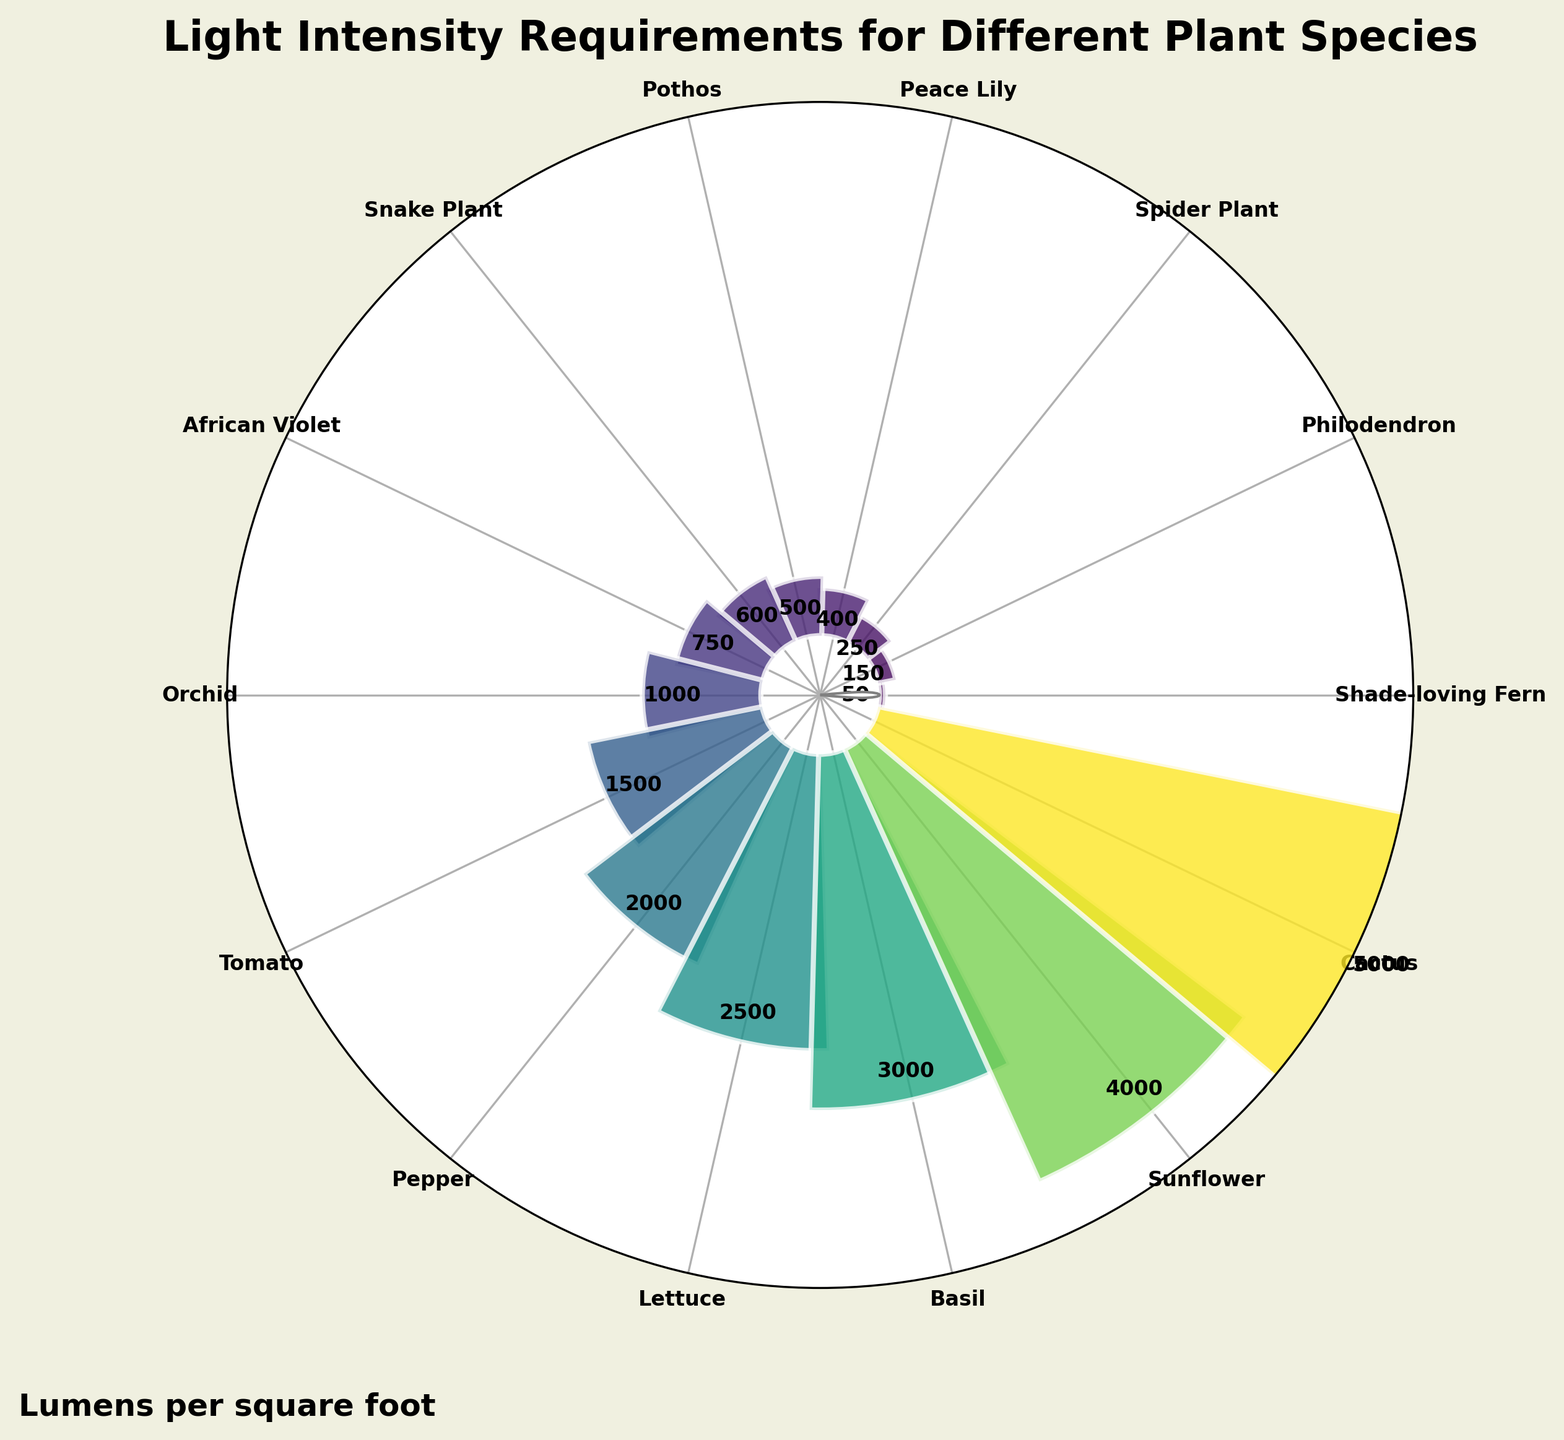What is the light intensity requirement for a Tomato plant in lumens per square foot? By looking at the gauge chart, the label at the angle associated with Tomato indicates a value of 1500 lumens per square foot.
Answer: 1500 Which plant species requires the least amount of light? The species located at the smallest value on the chart is Shade-loving Fern, which shows the smallest bar.
Answer: Shade-loving Fern Compare the light requirements between Cactus and Spider Plant. Which one needs more light? The bar representing Cactus extends further than the bar for Spider Plant. The value for Cactus is 5000 lumens per square foot, whereas Spider Plant requires 250 lumens per square foot.
Answer: Cactus How much more light does a Sunflower need compared to a Pothos? The gauge chart shows Sunflower at 4000 lumens per square foot and Pothos at 500 lumens per square foot. The difference is 4000 - 500 = 3500.
Answer: 3500 What is the title of the chart? The title at the top of the chart is "Light Intensity Requirements for Different Plant Species".
Answer: Light Intensity Requirements for Different Plant Species Do Orchids need more light than African Violets? The chart shows the light intensity for Orchids at 1000 lumens per square foot and for African Violets at 750 lumens per square foot. Since 1000 is greater than 750, Orchids need more light.
Answer: Yes What are the two plant species with the highest light intensity requirements? The gauge chart shows the longest bars representing light intensity values for Cactus at 5000 and Sunflower at 4000 lumens per square foot.
Answer: Cactus and Sunflower What is the average light intensity requirement for Philodendron, Spider Plant, and Peace Lily? The chart shows values of 150, 250, and 400 lumens per square foot, respectively. Summing them gives 150 + 250 + 400 = 800. The average is 800 / 3 = 266.67.
Answer: 266.67 How many plant species require more than 1000 lumens per square foot? From the chart, observe that Tomato (1500), Pepper (2000), Lettuce (2500), Basil (3000), Sunflower (4000), and Cactus (5000) each require more than 1000 lumens per square foot. This totals to 6 species.
Answer: 6 